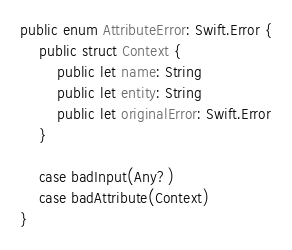Convert code to text. <code><loc_0><loc_0><loc_500><loc_500><_Swift_>public enum AttributeError: Swift.Error {
    public struct Context {
        public let name: String
        public let entity: String
        public let originalError: Swift.Error
    }

    case badInput(Any?)
    case badAttribute(Context)
}
</code> 